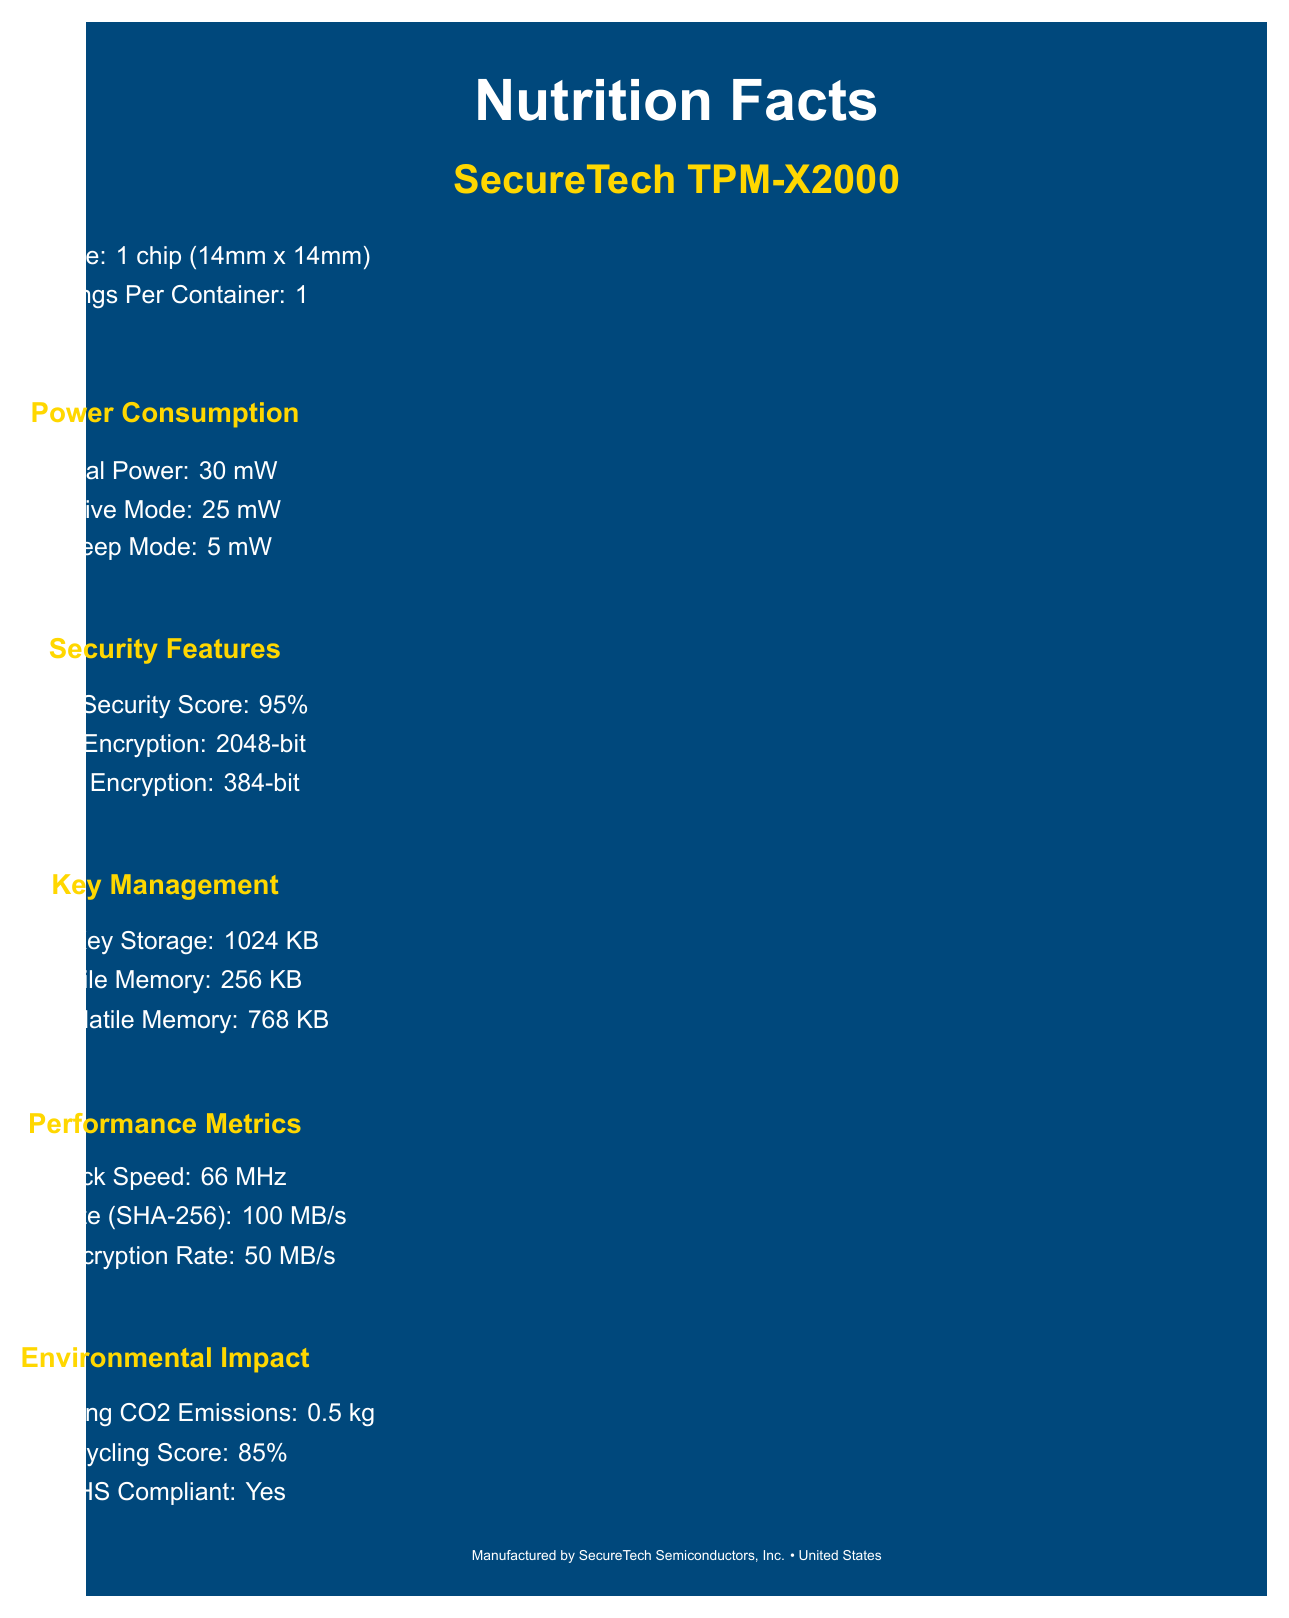what is the serving size? The document states that the serving size is 1 chip measuring 14mm by 14mm.
Answer: 1 chip (14mm x 14mm) how much power does the chip use in active mode? Under the Power Consumption section, it says that the chip uses 25 mW in Active Mode.
Answer: 25 mW what is the RSA encryption strength? The Security Features section of the document lists the RSA encryption strength as 2048-bit.
Answer: 2048-bit how much volatile memory does the chip have? The Key Management section indicates that the chip has 256 KB of volatile memory.
Answer: 256 KB what is the MTBF (Mean Time Between Failures) for the chip? The Reliability section states that the MTBF is 500,000 hours.
Answer: 500,000 hours what is the hash rate for SHA-256? The document specifies a hash rate for SHA-256 of 100 MB/s in the Performance Metrics section.
Answer: 100 MB/s which form factor does the chip use? A. TSSOP-28 B. LGA-16 C. QFN-32 The Compatibility section mentions that the chip uses a TSSOP-28 form factor.
Answer: A what is the recycling score of the chip? A. 75% B. 85% C. 95% D. 65% Under the Environmental Impact section, the recycling score is listed as 85%.
Answer: B is the chip RoHS compliant? The Environmental Impact section clearly states that the chip is RoHS compliant.
Answer: Yes what type of encryption rates does the chip support for AES? The Performance Metrics section lists the AES encryption rate as 50 MB/s.
Answer: 50 MB/s describe the main idea of this document The document is designed to give a comprehensive overview of the SecureTech TPM-X2000 chip's specifications and features in a format similar to a nutrition label found on food products.
Answer: The document provides detailed "Nutrition Facts" for the SecureTech TPM-X2000 chip, including power consumption, security features, key management, performance metrics, compatibility, environmental impact, reliability, ingredients, and certifications. how many certifications does the chip have? The Certifications section lists three certifications: FIPS 140-2 Level 3, Common Criteria EAL 4+, and ISO/IEC 11889:2015.
Answer: 3 what is the operating temperature range for the chip? The document lists the operating temperature range in the Compatibility section.
Answer: -40°C to 85°C what is the key generation speed for RSA keys? According to the Key Management section, the key generation speed is 500 ms per 2048-bit RSA key.
Answer: 500 ms per 2048-bit RSA key was the chip manufactured using lead-free solder? The document only states that the chip is manufactured in a facility that processes lead-free solder, but it does not explicitly confirm that the chip itself was manufactured using lead-free solder.
Answer: Cannot be determined 